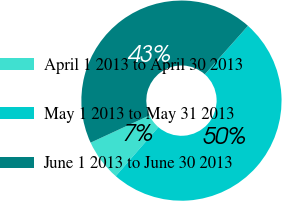Convert chart to OTSL. <chart><loc_0><loc_0><loc_500><loc_500><pie_chart><fcel>April 1 2013 to April 30 2013<fcel>May 1 2013 to May 31 2013<fcel>June 1 2013 to June 30 2013<nl><fcel>6.7%<fcel>49.83%<fcel>43.46%<nl></chart> 